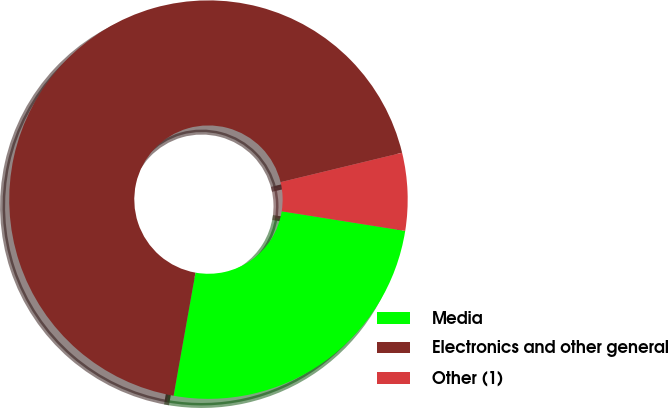Convert chart. <chart><loc_0><loc_0><loc_500><loc_500><pie_chart><fcel>Media<fcel>Electronics and other general<fcel>Other (1)<nl><fcel>25.29%<fcel>68.42%<fcel>6.29%<nl></chart> 